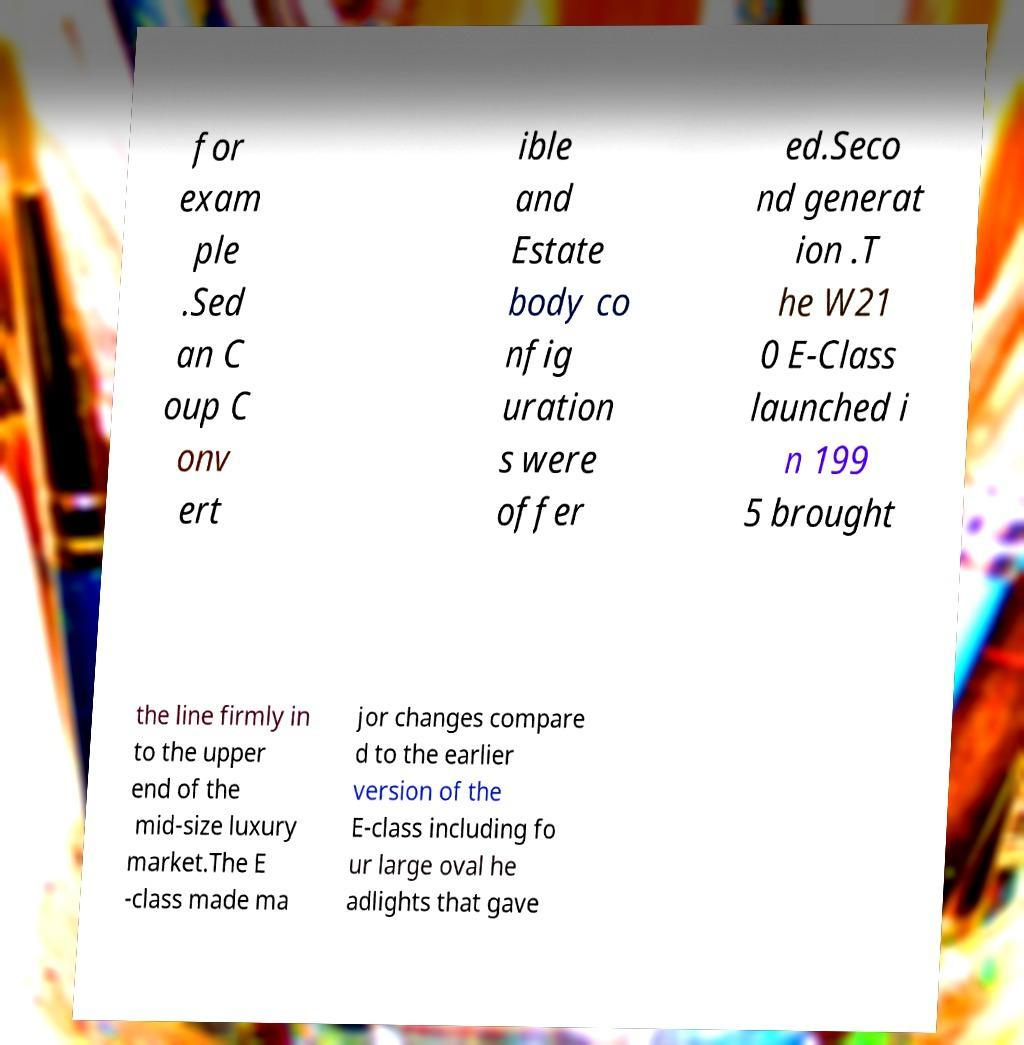Please identify and transcribe the text found in this image. for exam ple .Sed an C oup C onv ert ible and Estate body co nfig uration s were offer ed.Seco nd generat ion .T he W21 0 E-Class launched i n 199 5 brought the line firmly in to the upper end of the mid-size luxury market.The E -class made ma jor changes compare d to the earlier version of the E-class including fo ur large oval he adlights that gave 